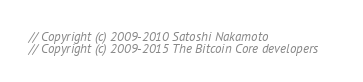<code> <loc_0><loc_0><loc_500><loc_500><_C_>// Copyright (c) 2009-2010 Satoshi Nakamoto
// Copyright (c) 2009-2015 The Bitcoin Core developers</code> 